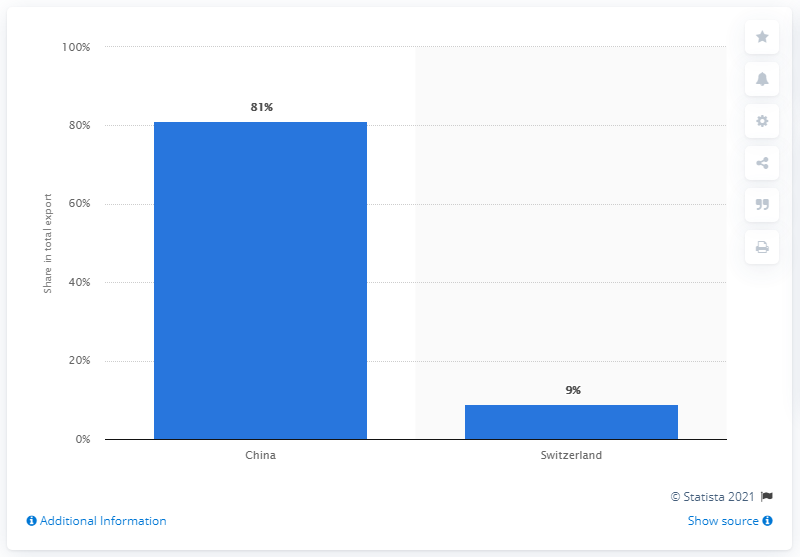Give some essential details in this illustration. In 2019, Mongolia's main export partner was China, accounting for the majority of the country's total exports. 